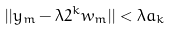Convert formula to latex. <formula><loc_0><loc_0><loc_500><loc_500>| | y _ { m } - \lambda 2 ^ { k } w _ { m } | | < \lambda a _ { k }</formula> 